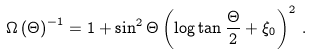<formula> <loc_0><loc_0><loc_500><loc_500>\Omega \left ( \Theta \right ) ^ { - 1 } = 1 + \sin ^ { 2 } \Theta \left ( \log \tan \frac { \Theta } { 2 } + \xi _ { 0 } \right ) ^ { 2 } \, .</formula> 